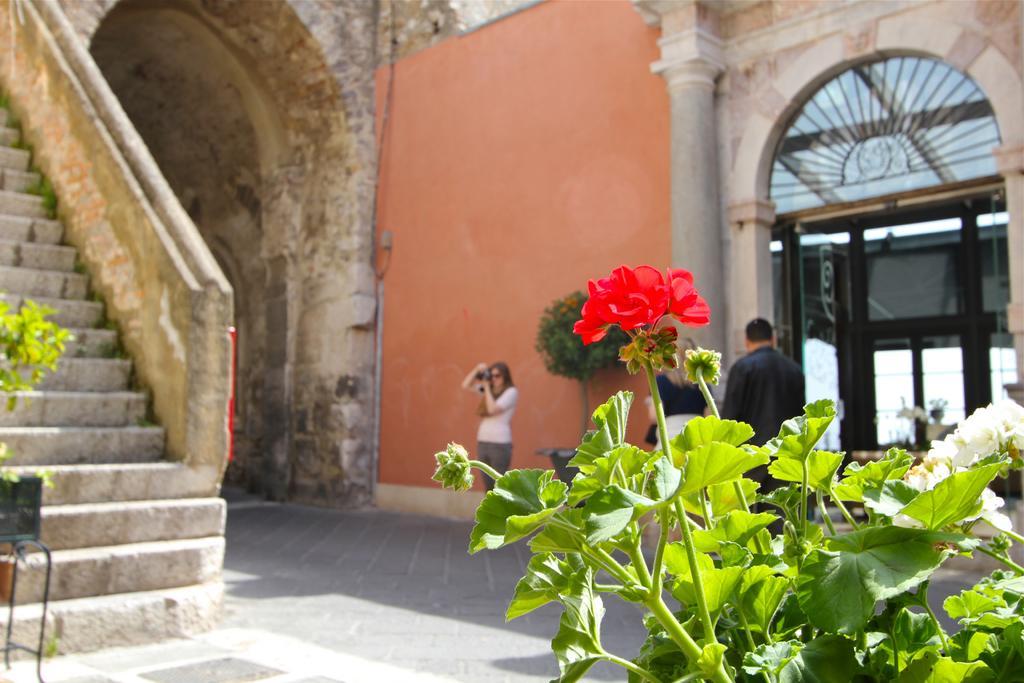Can you describe this image briefly? In this picture there are stairs on the left side of the image and there are people in the center of the image, there is a building in the center of the image and there are flower plants in the image. 